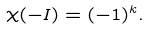<formula> <loc_0><loc_0><loc_500><loc_500>\chi ( - I ) = ( - 1 ) ^ { k } .</formula> 